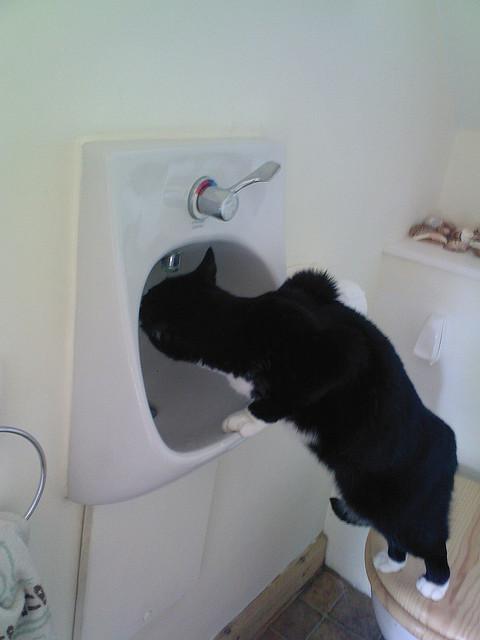What is the cat doing?
Write a very short answer. Drinking. What type of animal is this?
Write a very short answer. Cat. What is the cat standing on?
Be succinct. Toilet. What is the cat playing with?
Answer briefly. Sink. 